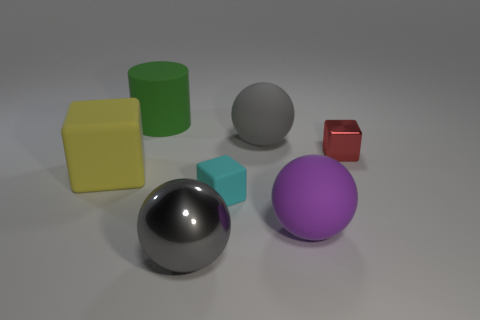Add 2 big yellow matte spheres. How many objects exist? 9 Subtract all blocks. How many objects are left? 4 Subtract all metal balls. Subtract all big metal spheres. How many objects are left? 5 Add 2 gray rubber objects. How many gray rubber objects are left? 3 Add 2 big red rubber cylinders. How many big red rubber cylinders exist? 2 Subtract 0 gray blocks. How many objects are left? 7 